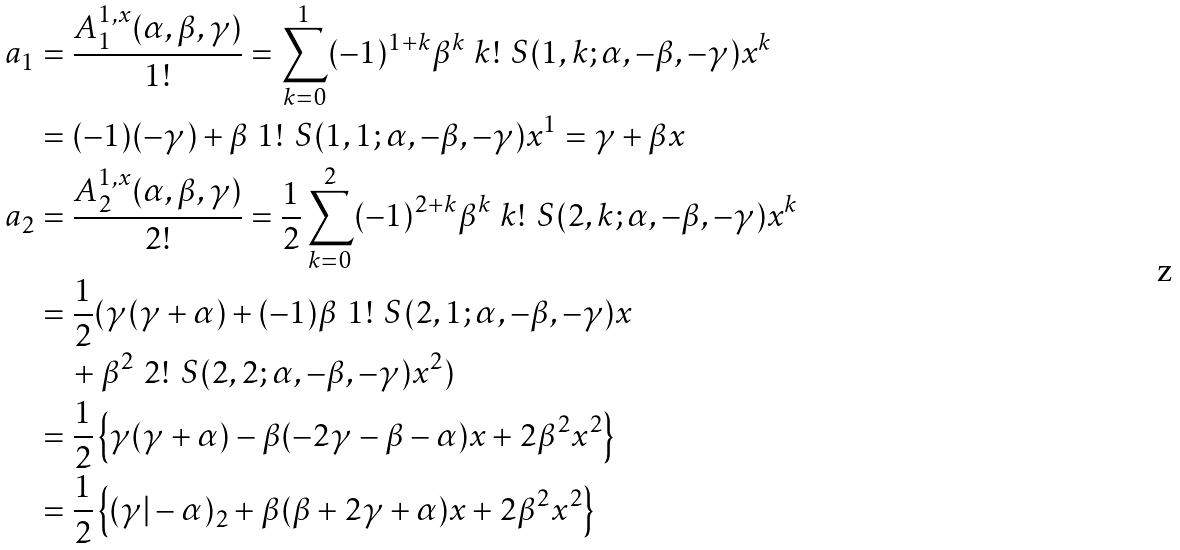<formula> <loc_0><loc_0><loc_500><loc_500>a _ { 1 } & = \frac { A ^ { 1 , x } _ { 1 } ( \alpha , \beta , \gamma ) } { 1 ! } = \sum _ { k = 0 } ^ { 1 } ( - 1 ) ^ { 1 + k } \beta ^ { k } \ k ! \ S ( 1 , k ; \alpha , - \beta , - \gamma ) x ^ { k } \\ & = ( - 1 ) ( - \gamma ) + \beta \ 1 ! \ S ( 1 , 1 ; \alpha , - \beta , - \gamma ) x ^ { 1 } = \gamma + \beta x \\ a _ { 2 } & = \frac { A ^ { 1 , x } _ { 2 } ( \alpha , \beta , \gamma ) } { 2 ! } = \frac { 1 } { 2 } \sum _ { k = 0 } ^ { 2 } ( - 1 ) ^ { 2 + k } \beta ^ { k } \ k ! \ S ( 2 , k ; \alpha , - \beta , - \gamma ) x ^ { k } \\ & = \frac { 1 } { 2 } ( \gamma ( \gamma + \alpha ) + ( - 1 ) \beta \ 1 ! \ S ( 2 , 1 ; \alpha , - \beta , - \gamma ) x \\ & \quad + \beta ^ { 2 } \ 2 ! \ S ( 2 , 2 ; \alpha , - \beta , - \gamma ) x ^ { 2 } ) \\ & = \frac { 1 } { 2 } \left \{ \gamma ( \gamma + \alpha ) - \beta ( - 2 \gamma - \beta - \alpha ) x + 2 \beta ^ { 2 } x ^ { 2 } \right \} \\ & = \frac { 1 } { 2 } \left \{ ( \gamma | - \alpha ) _ { 2 } + \beta ( \beta + 2 \gamma + \alpha ) x + 2 \beta ^ { 2 } x ^ { 2 } \right \}</formula> 